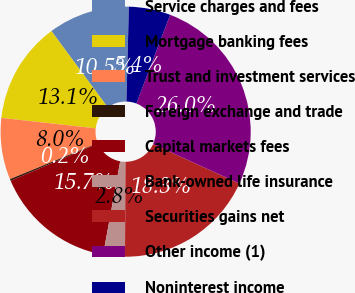Convert chart to OTSL. <chart><loc_0><loc_0><loc_500><loc_500><pie_chart><fcel>Service charges and fees<fcel>Mortgage banking fees<fcel>Trust and investment services<fcel>Foreign exchange and trade<fcel>Capital markets fees<fcel>Bank-owned life insurance<fcel>Securities gains net<fcel>Other income (1)<fcel>Noninterest income<nl><fcel>10.54%<fcel>13.12%<fcel>7.96%<fcel>0.22%<fcel>15.7%<fcel>2.8%<fcel>18.28%<fcel>26.02%<fcel>5.38%<nl></chart> 